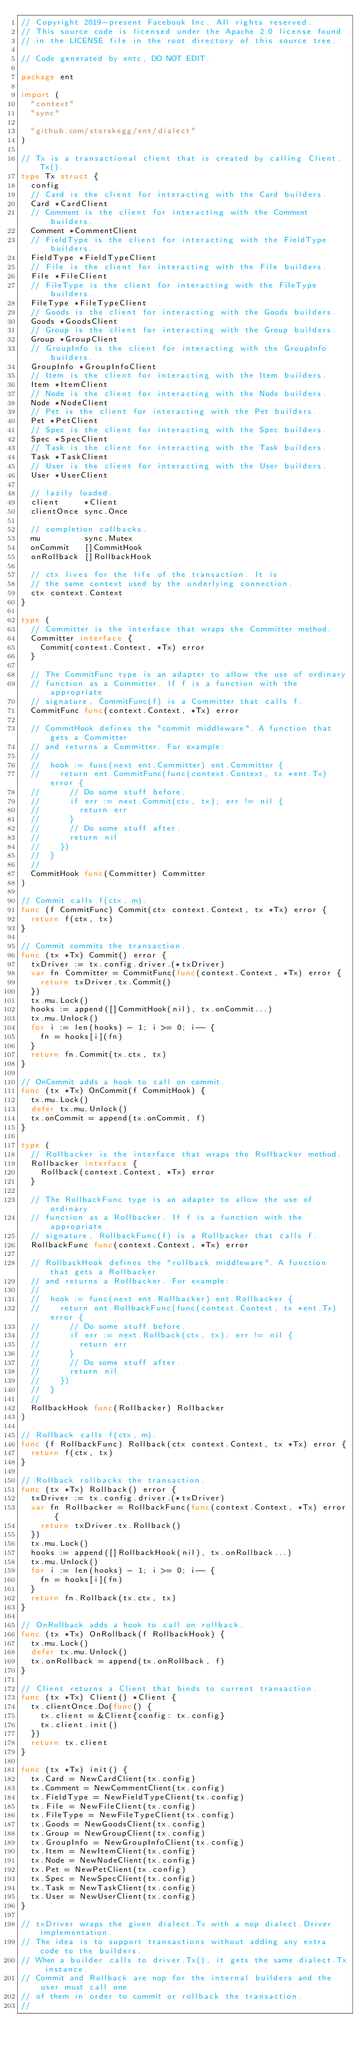Convert code to text. <code><loc_0><loc_0><loc_500><loc_500><_Go_>// Copyright 2019-present Facebook Inc. All rights reserved.
// This source code is licensed under the Apache 2.0 license found
// in the LICENSE file in the root directory of this source tree.

// Code generated by entc, DO NOT EDIT.

package ent

import (
	"context"
	"sync"

	"github.com/storskegg/ent/dialect"
)

// Tx is a transactional client that is created by calling Client.Tx().
type Tx struct {
	config
	// Card is the client for interacting with the Card builders.
	Card *CardClient
	// Comment is the client for interacting with the Comment builders.
	Comment *CommentClient
	// FieldType is the client for interacting with the FieldType builders.
	FieldType *FieldTypeClient
	// File is the client for interacting with the File builders.
	File *FileClient
	// FileType is the client for interacting with the FileType builders.
	FileType *FileTypeClient
	// Goods is the client for interacting with the Goods builders.
	Goods *GoodsClient
	// Group is the client for interacting with the Group builders.
	Group *GroupClient
	// GroupInfo is the client for interacting with the GroupInfo builders.
	GroupInfo *GroupInfoClient
	// Item is the client for interacting with the Item builders.
	Item *ItemClient
	// Node is the client for interacting with the Node builders.
	Node *NodeClient
	// Pet is the client for interacting with the Pet builders.
	Pet *PetClient
	// Spec is the client for interacting with the Spec builders.
	Spec *SpecClient
	// Task is the client for interacting with the Task builders.
	Task *TaskClient
	// User is the client for interacting with the User builders.
	User *UserClient

	// lazily loaded.
	client     *Client
	clientOnce sync.Once

	// completion callbacks.
	mu         sync.Mutex
	onCommit   []CommitHook
	onRollback []RollbackHook

	// ctx lives for the life of the transaction. It is
	// the same context used by the underlying connection.
	ctx context.Context
}

type (
	// Committer is the interface that wraps the Committer method.
	Committer interface {
		Commit(context.Context, *Tx) error
	}

	// The CommitFunc type is an adapter to allow the use of ordinary
	// function as a Committer. If f is a function with the appropriate
	// signature, CommitFunc(f) is a Committer that calls f.
	CommitFunc func(context.Context, *Tx) error

	// CommitHook defines the "commit middleware". A function that gets a Committer
	// and returns a Committer. For example:
	//
	//	hook := func(next ent.Committer) ent.Committer {
	//		return ent.CommitFunc(func(context.Context, tx *ent.Tx) error {
	//			// Do some stuff before.
	//			if err := next.Commit(ctx, tx); err != nil {
	//				return err
	//			}
	//			// Do some stuff after.
	//			return nil
	//		})
	//	}
	//
	CommitHook func(Committer) Committer
)

// Commit calls f(ctx, m).
func (f CommitFunc) Commit(ctx context.Context, tx *Tx) error {
	return f(ctx, tx)
}

// Commit commits the transaction.
func (tx *Tx) Commit() error {
	txDriver := tx.config.driver.(*txDriver)
	var fn Committer = CommitFunc(func(context.Context, *Tx) error {
		return txDriver.tx.Commit()
	})
	tx.mu.Lock()
	hooks := append([]CommitHook(nil), tx.onCommit...)
	tx.mu.Unlock()
	for i := len(hooks) - 1; i >= 0; i-- {
		fn = hooks[i](fn)
	}
	return fn.Commit(tx.ctx, tx)
}

// OnCommit adds a hook to call on commit.
func (tx *Tx) OnCommit(f CommitHook) {
	tx.mu.Lock()
	defer tx.mu.Unlock()
	tx.onCommit = append(tx.onCommit, f)
}

type (
	// Rollbacker is the interface that wraps the Rollbacker method.
	Rollbacker interface {
		Rollback(context.Context, *Tx) error
	}

	// The RollbackFunc type is an adapter to allow the use of ordinary
	// function as a Rollbacker. If f is a function with the appropriate
	// signature, RollbackFunc(f) is a Rollbacker that calls f.
	RollbackFunc func(context.Context, *Tx) error

	// RollbackHook defines the "rollback middleware". A function that gets a Rollbacker
	// and returns a Rollbacker. For example:
	//
	//	hook := func(next ent.Rollbacker) ent.Rollbacker {
	//		return ent.RollbackFunc(func(context.Context, tx *ent.Tx) error {
	//			// Do some stuff before.
	//			if err := next.Rollback(ctx, tx); err != nil {
	//				return err
	//			}
	//			// Do some stuff after.
	//			return nil
	//		})
	//	}
	//
	RollbackHook func(Rollbacker) Rollbacker
)

// Rollback calls f(ctx, m).
func (f RollbackFunc) Rollback(ctx context.Context, tx *Tx) error {
	return f(ctx, tx)
}

// Rollback rollbacks the transaction.
func (tx *Tx) Rollback() error {
	txDriver := tx.config.driver.(*txDriver)
	var fn Rollbacker = RollbackFunc(func(context.Context, *Tx) error {
		return txDriver.tx.Rollback()
	})
	tx.mu.Lock()
	hooks := append([]RollbackHook(nil), tx.onRollback...)
	tx.mu.Unlock()
	for i := len(hooks) - 1; i >= 0; i-- {
		fn = hooks[i](fn)
	}
	return fn.Rollback(tx.ctx, tx)
}

// OnRollback adds a hook to call on rollback.
func (tx *Tx) OnRollback(f RollbackHook) {
	tx.mu.Lock()
	defer tx.mu.Unlock()
	tx.onRollback = append(tx.onRollback, f)
}

// Client returns a Client that binds to current transaction.
func (tx *Tx) Client() *Client {
	tx.clientOnce.Do(func() {
		tx.client = &Client{config: tx.config}
		tx.client.init()
	})
	return tx.client
}

func (tx *Tx) init() {
	tx.Card = NewCardClient(tx.config)
	tx.Comment = NewCommentClient(tx.config)
	tx.FieldType = NewFieldTypeClient(tx.config)
	tx.File = NewFileClient(tx.config)
	tx.FileType = NewFileTypeClient(tx.config)
	tx.Goods = NewGoodsClient(tx.config)
	tx.Group = NewGroupClient(tx.config)
	tx.GroupInfo = NewGroupInfoClient(tx.config)
	tx.Item = NewItemClient(tx.config)
	tx.Node = NewNodeClient(tx.config)
	tx.Pet = NewPetClient(tx.config)
	tx.Spec = NewSpecClient(tx.config)
	tx.Task = NewTaskClient(tx.config)
	tx.User = NewUserClient(tx.config)
}

// txDriver wraps the given dialect.Tx with a nop dialect.Driver implementation.
// The idea is to support transactions without adding any extra code to the builders.
// When a builder calls to driver.Tx(), it gets the same dialect.Tx instance.
// Commit and Rollback are nop for the internal builders and the user must call one
// of them in order to commit or rollback the transaction.
//</code> 